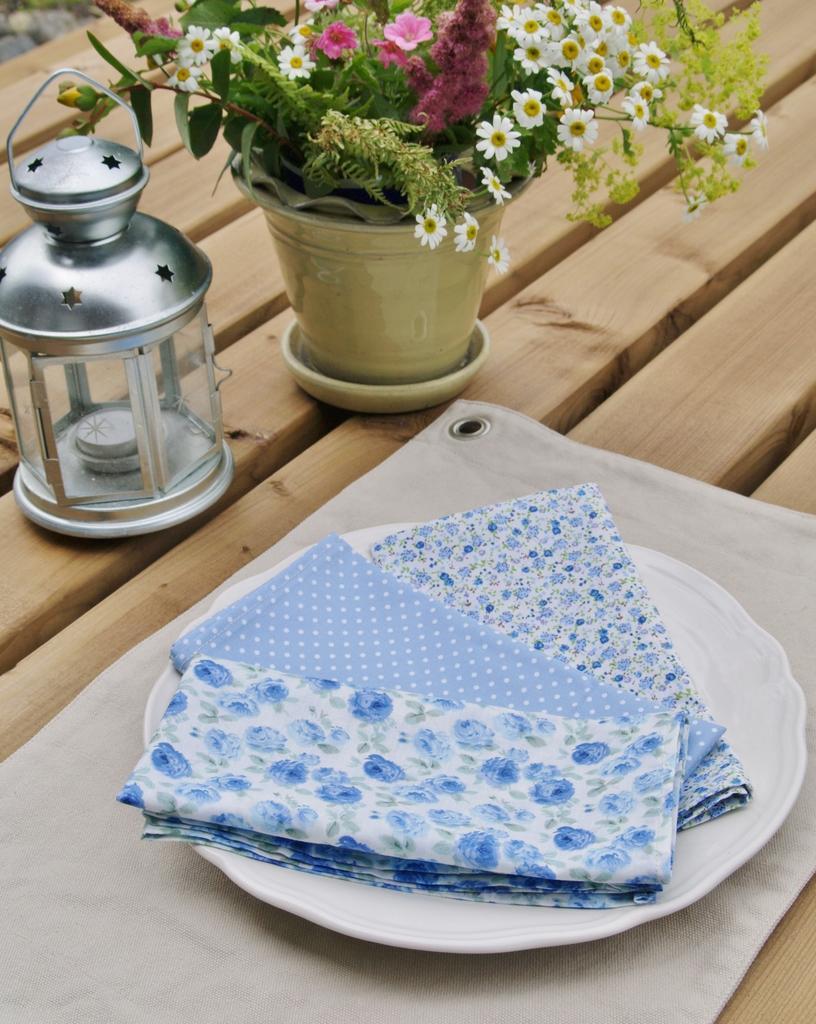Could you give a brief overview of what you see in this image? In this picture we can see a plate, flower vase, and a candle on the table. 